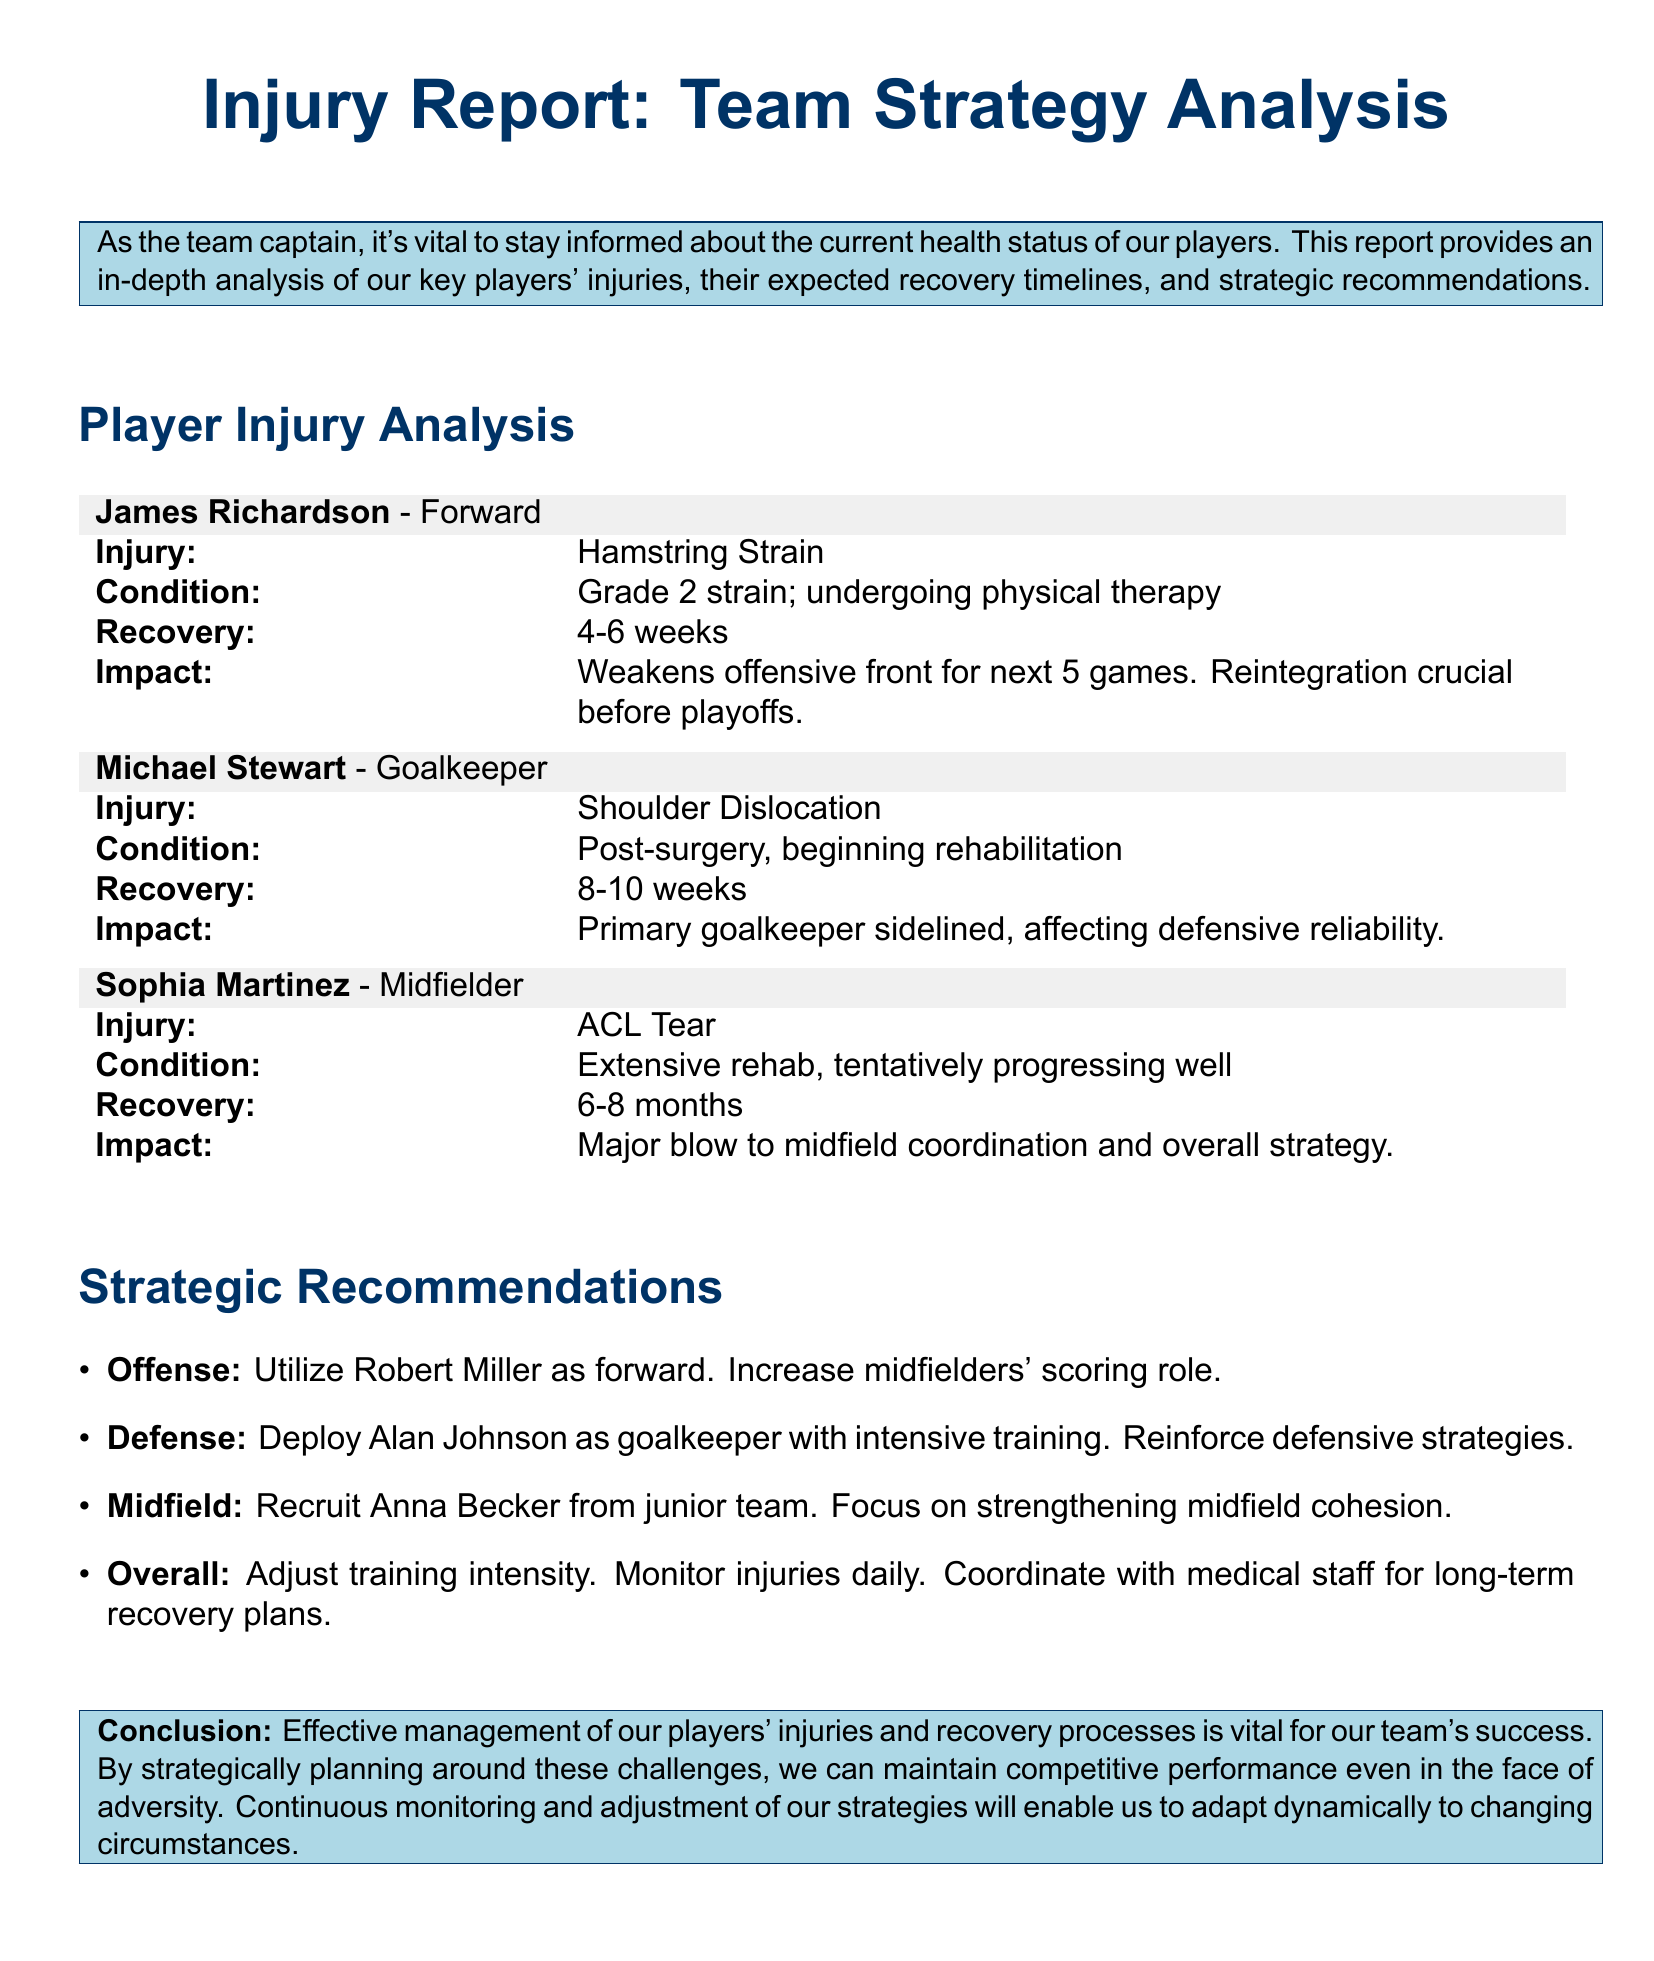What is the injury type for James Richardson? James Richardson has a Hamstring Strain, which is specifically stated in the injury report.
Answer: Hamstring Strain How long is Michael Stewart expected to be sidelined? The document mentions that Michael Stewart has an estimated recovery time of 8-10 weeks post-surgery.
Answer: 8-10 weeks What is the condition of Sophia Martinez's injury? Sophia Martinez's injury status indicates she is tentatively progressing well in her extensive rehabilitation.
Answer: Tentatively progressing well Who is recommended to be used as a forward in the offense strategy? Robert Miller is specifically mentioned as the player to be utilized as a forward in the strategic recommendations.
Answer: Robert Miller What impact does James Richardson's injury have on the team's performance? His injury weakens the offensive front for the next five games, according to the analysis provided.
Answer: Weakens offensive front for next 5 games How many months is Sophia Martinez's recovery expected to take? The document states that Sophia Martinez's recovery could take 6-8 months due to her ACL Tear.
Answer: 6-8 months What is the proposed adjustment to training intensity? The report recommends adjusting training intensity to accommodate the current injury situation amongst the players.
Answer: Adjust training intensity Which player is suggested to reinforce the goalkeeper position? Alan Johnson is the player recommended to be deployed as a goalkeeper with intensive training.
Answer: Alan Johnson What overall strategy is emphasized for team management? Continuous monitoring and adjustment of strategies is highlighted as a vital approach for managing player injuries effectively.
Answer: Continuous monitoring and adjustment of strategies 